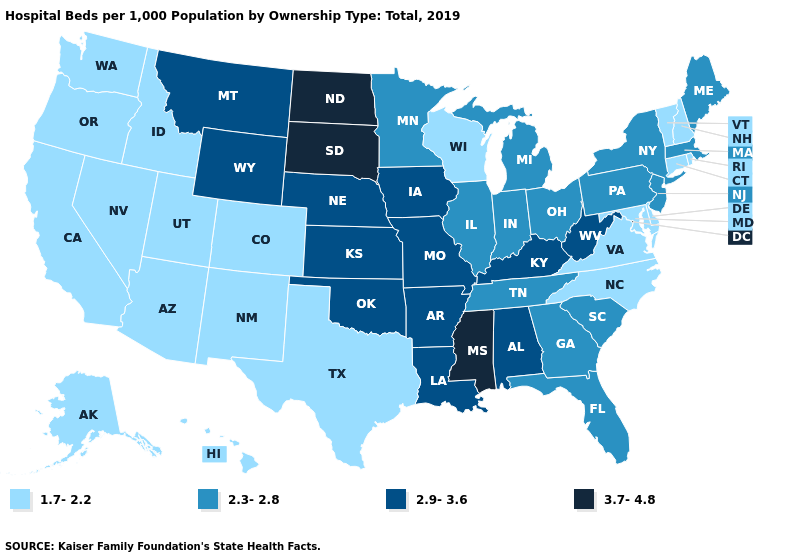Name the states that have a value in the range 2.3-2.8?
Concise answer only. Florida, Georgia, Illinois, Indiana, Maine, Massachusetts, Michigan, Minnesota, New Jersey, New York, Ohio, Pennsylvania, South Carolina, Tennessee. What is the value of Missouri?
Quick response, please. 2.9-3.6. Does the first symbol in the legend represent the smallest category?
Write a very short answer. Yes. Does Wyoming have the lowest value in the West?
Answer briefly. No. Does Idaho have the same value as Nevada?
Concise answer only. Yes. Name the states that have a value in the range 2.3-2.8?
Quick response, please. Florida, Georgia, Illinois, Indiana, Maine, Massachusetts, Michigan, Minnesota, New Jersey, New York, Ohio, Pennsylvania, South Carolina, Tennessee. Does Rhode Island have the highest value in the Northeast?
Write a very short answer. No. What is the value of West Virginia?
Give a very brief answer. 2.9-3.6. Does Montana have the highest value in the West?
Concise answer only. Yes. Does the first symbol in the legend represent the smallest category?
Keep it brief. Yes. What is the highest value in the Northeast ?
Give a very brief answer. 2.3-2.8. Does New Hampshire have the highest value in the USA?
Write a very short answer. No. Name the states that have a value in the range 3.7-4.8?
Keep it brief. Mississippi, North Dakota, South Dakota. Among the states that border Massachusetts , does New Hampshire have the lowest value?
Quick response, please. Yes. What is the lowest value in the USA?
Answer briefly. 1.7-2.2. 